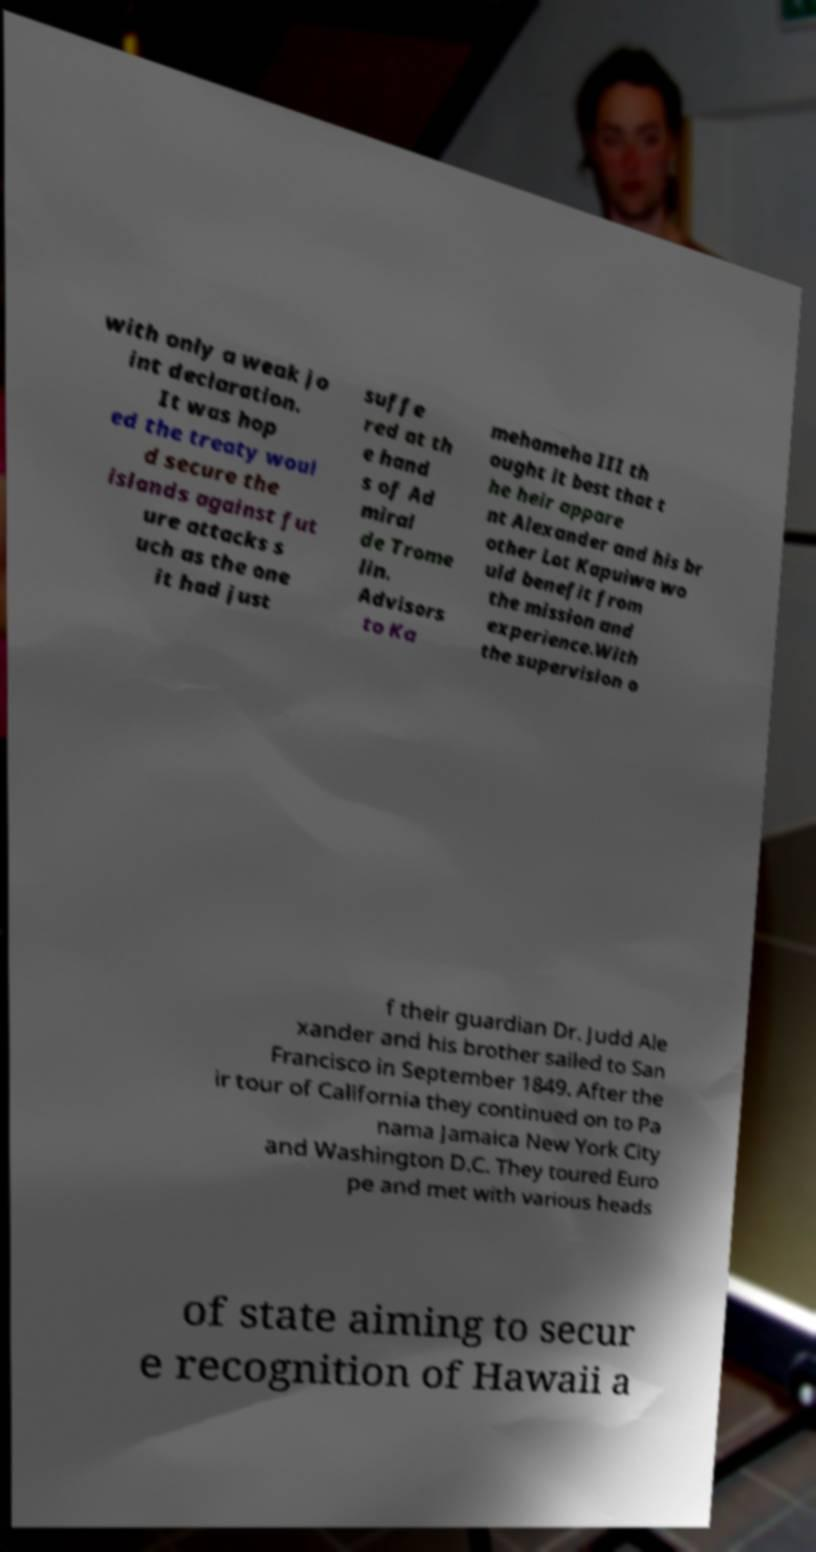Can you accurately transcribe the text from the provided image for me? with only a weak jo int declaration. It was hop ed the treaty woul d secure the islands against fut ure attacks s uch as the one it had just suffe red at th e hand s of Ad miral de Trome lin. Advisors to Ka mehameha III th ought it best that t he heir appare nt Alexander and his br other Lot Kapuiwa wo uld benefit from the mission and experience.With the supervision o f their guardian Dr. Judd Ale xander and his brother sailed to San Francisco in September 1849. After the ir tour of California they continued on to Pa nama Jamaica New York City and Washington D.C. They toured Euro pe and met with various heads of state aiming to secur e recognition of Hawaii a 